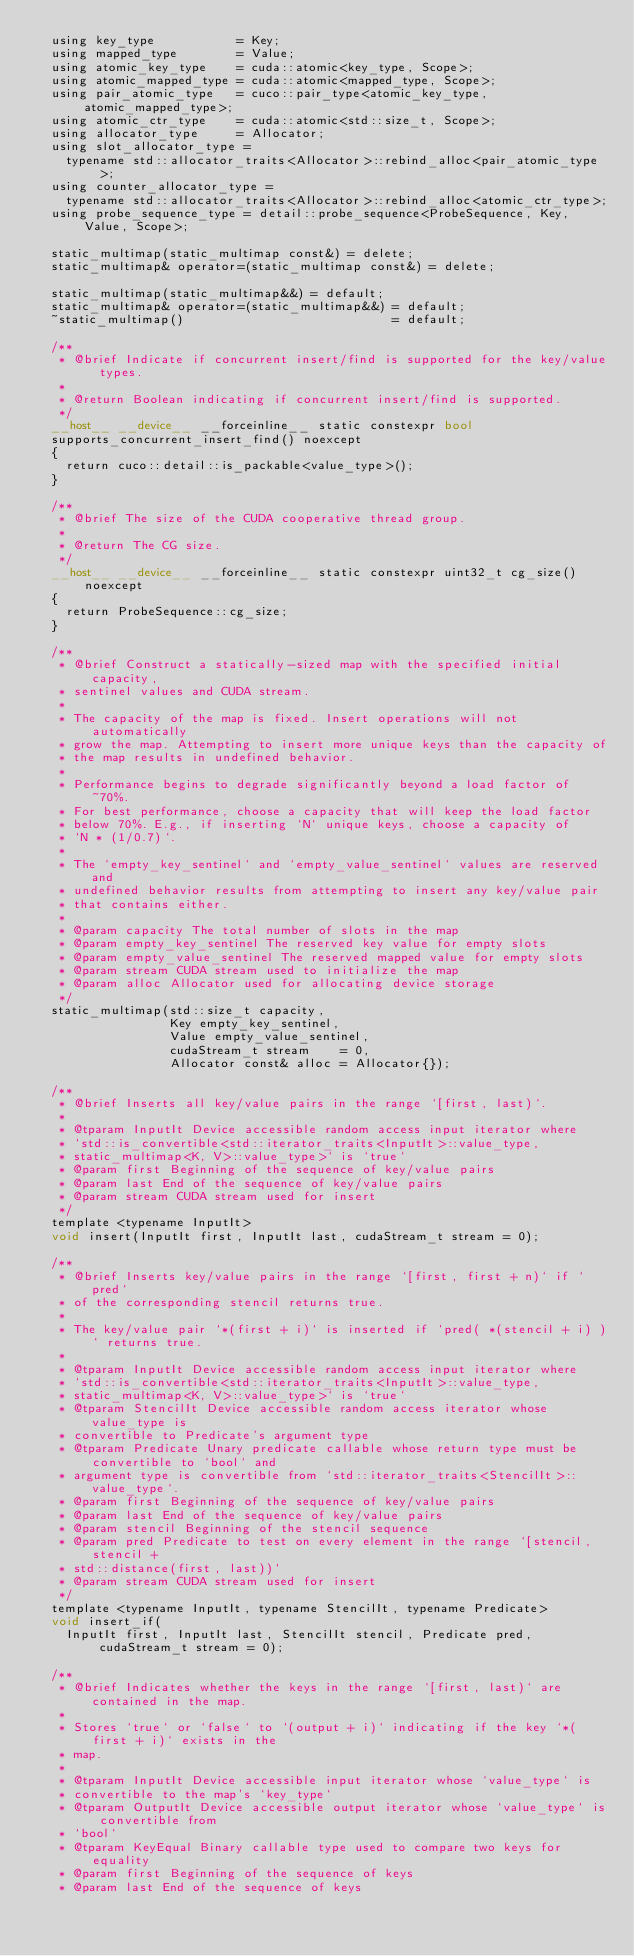<code> <loc_0><loc_0><loc_500><loc_500><_Cuda_>  using key_type           = Key;
  using mapped_type        = Value;
  using atomic_key_type    = cuda::atomic<key_type, Scope>;
  using atomic_mapped_type = cuda::atomic<mapped_type, Scope>;
  using pair_atomic_type   = cuco::pair_type<atomic_key_type, atomic_mapped_type>;
  using atomic_ctr_type    = cuda::atomic<std::size_t, Scope>;
  using allocator_type     = Allocator;
  using slot_allocator_type =
    typename std::allocator_traits<Allocator>::rebind_alloc<pair_atomic_type>;
  using counter_allocator_type =
    typename std::allocator_traits<Allocator>::rebind_alloc<atomic_ctr_type>;
  using probe_sequence_type = detail::probe_sequence<ProbeSequence, Key, Value, Scope>;

  static_multimap(static_multimap const&) = delete;
  static_multimap& operator=(static_multimap const&) = delete;

  static_multimap(static_multimap&&) = default;
  static_multimap& operator=(static_multimap&&) = default;
  ~static_multimap()                            = default;

  /**
   * @brief Indicate if concurrent insert/find is supported for the key/value types.
   *
   * @return Boolean indicating if concurrent insert/find is supported.
   */
  __host__ __device__ __forceinline__ static constexpr bool
  supports_concurrent_insert_find() noexcept
  {
    return cuco::detail::is_packable<value_type>();
  }

  /**
   * @brief The size of the CUDA cooperative thread group.
   *
   * @return The CG size.
   */
  __host__ __device__ __forceinline__ static constexpr uint32_t cg_size() noexcept
  {
    return ProbeSequence::cg_size;
  }

  /**
   * @brief Construct a statically-sized map with the specified initial capacity,
   * sentinel values and CUDA stream.
   *
   * The capacity of the map is fixed. Insert operations will not automatically
   * grow the map. Attempting to insert more unique keys than the capacity of
   * the map results in undefined behavior.
   *
   * Performance begins to degrade significantly beyond a load factor of ~70%.
   * For best performance, choose a capacity that will keep the load factor
   * below 70%. E.g., if inserting `N` unique keys, choose a capacity of
   * `N * (1/0.7)`.
   *
   * The `empty_key_sentinel` and `empty_value_sentinel` values are reserved and
   * undefined behavior results from attempting to insert any key/value pair
   * that contains either.
   *
   * @param capacity The total number of slots in the map
   * @param empty_key_sentinel The reserved key value for empty slots
   * @param empty_value_sentinel The reserved mapped value for empty slots
   * @param stream CUDA stream used to initialize the map
   * @param alloc Allocator used for allocating device storage
   */
  static_multimap(std::size_t capacity,
                  Key empty_key_sentinel,
                  Value empty_value_sentinel,
                  cudaStream_t stream    = 0,
                  Allocator const& alloc = Allocator{});

  /**
   * @brief Inserts all key/value pairs in the range `[first, last)`.
   *
   * @tparam InputIt Device accessible random access input iterator where
   * `std::is_convertible<std::iterator_traits<InputIt>::value_type,
   * static_multimap<K, V>::value_type>` is `true`
   * @param first Beginning of the sequence of key/value pairs
   * @param last End of the sequence of key/value pairs
   * @param stream CUDA stream used for insert
   */
  template <typename InputIt>
  void insert(InputIt first, InputIt last, cudaStream_t stream = 0);

  /**
   * @brief Inserts key/value pairs in the range `[first, first + n)` if `pred`
   * of the corresponding stencil returns true.
   *
   * The key/value pair `*(first + i)` is inserted if `pred( *(stencil + i) )` returns true.
   *
   * @tparam InputIt Device accessible random access input iterator where
   * `std::is_convertible<std::iterator_traits<InputIt>::value_type,
   * static_multimap<K, V>::value_type>` is `true`
   * @tparam StencilIt Device accessible random access iterator whose value_type is
   * convertible to Predicate's argument type
   * @tparam Predicate Unary predicate callable whose return type must be convertible to `bool` and
   * argument type is convertible from `std::iterator_traits<StencilIt>::value_type`.
   * @param first Beginning of the sequence of key/value pairs
   * @param last End of the sequence of key/value pairs
   * @param stencil Beginning of the stencil sequence
   * @param pred Predicate to test on every element in the range `[stencil, stencil +
   * std::distance(first, last))`
   * @param stream CUDA stream used for insert
   */
  template <typename InputIt, typename StencilIt, typename Predicate>
  void insert_if(
    InputIt first, InputIt last, StencilIt stencil, Predicate pred, cudaStream_t stream = 0);

  /**
   * @brief Indicates whether the keys in the range `[first, last)` are contained in the map.
   *
   * Stores `true` or `false` to `(output + i)` indicating if the key `*(first + i)` exists in the
   * map.
   *
   * @tparam InputIt Device accessible input iterator whose `value_type` is
   * convertible to the map's `key_type`
   * @tparam OutputIt Device accessible output iterator whose `value_type` is convertible from
   * `bool`
   * @tparam KeyEqual Binary callable type used to compare two keys for equality
   * @param first Beginning of the sequence of keys
   * @param last End of the sequence of keys</code> 